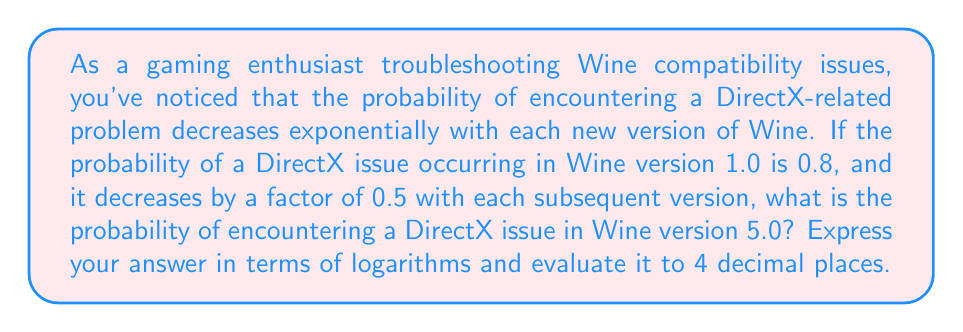Could you help me with this problem? Let's approach this step-by-step:

1) Let $p_n$ be the probability of a DirectX issue in Wine version $n$.

2) We're given that $p_1 = 0.8$ (for version 1.0), and each subsequent version reduces the probability by a factor of 0.5.

3) This forms a geometric sequence with first term $a = 0.8$ and common ratio $r = 0.5$.

4) The general term of a geometric sequence is given by $ar^{n-1}$, where $n$ is the term number.

5) For Wine version 5.0, we need to find $p_5$:

   $p_5 = 0.8 \cdot (0.5)^{5-1} = 0.8 \cdot (0.5)^4$

6) To express this in terms of logarithms, we can use the property of exponents:

   $p_5 = 0.8 \cdot 2^{-4} = 0.8 \cdot 2^{-\log_2(16)}$

7) Using the logarithm property $a^{\log_a(x)} = x$, we get:

   $p_5 = 0.8 \cdot \frac{1}{16} = 0.05$

8) To verify using logarithms:

   $\log(p_5) = \log(0.8) + \log(2^{-4}) = \log(0.8) - 4\log(2)$

   $p_5 = 10^{\log(0.8) - 4\log(2)} \approx 0.05$

Therefore, the probability of encountering a DirectX issue in Wine version 5.0 is approximately 0.05 or 5%.
Answer: $p_5 = 0.8 \cdot 2^{-\log_2(16)} \approx 0.0500$ 